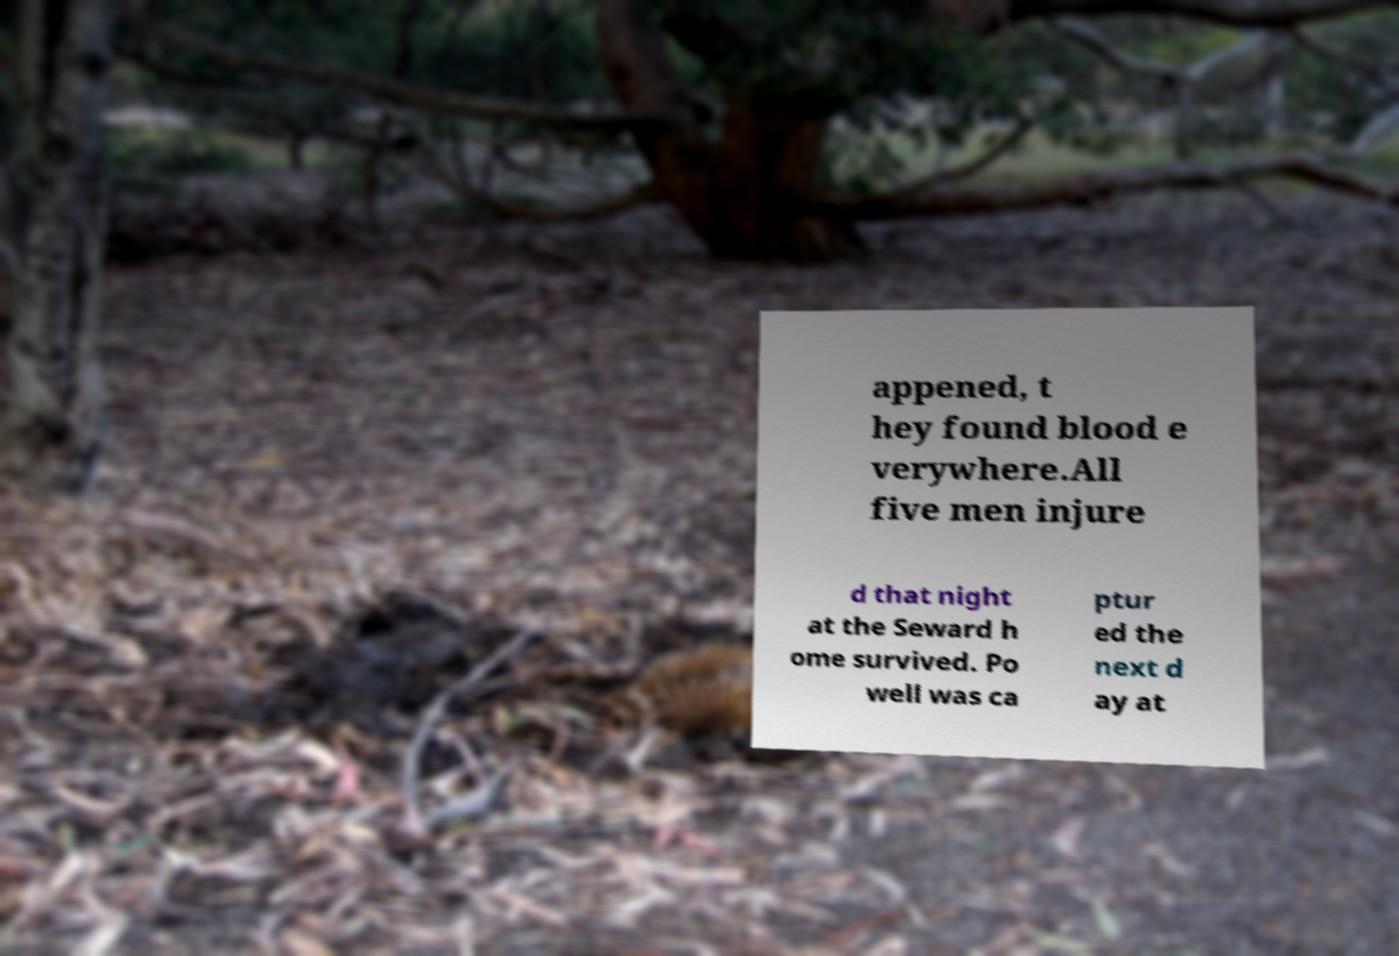Could you extract and type out the text from this image? appened, t hey found blood e verywhere.All five men injure d that night at the Seward h ome survived. Po well was ca ptur ed the next d ay at 